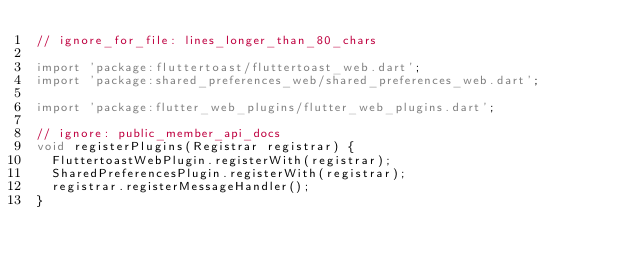<code> <loc_0><loc_0><loc_500><loc_500><_Dart_>// ignore_for_file: lines_longer_than_80_chars

import 'package:fluttertoast/fluttertoast_web.dart';
import 'package:shared_preferences_web/shared_preferences_web.dart';

import 'package:flutter_web_plugins/flutter_web_plugins.dart';

// ignore: public_member_api_docs
void registerPlugins(Registrar registrar) {
  FluttertoastWebPlugin.registerWith(registrar);
  SharedPreferencesPlugin.registerWith(registrar);
  registrar.registerMessageHandler();
}
</code> 